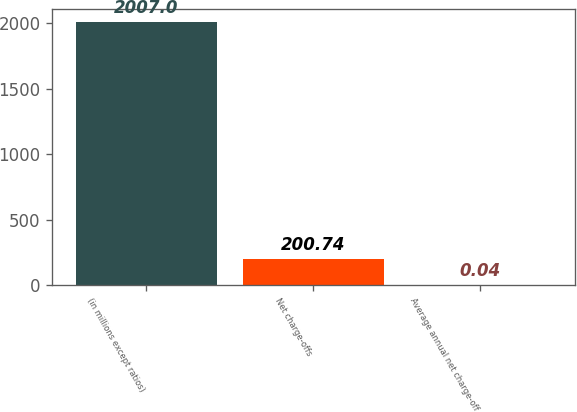<chart> <loc_0><loc_0><loc_500><loc_500><bar_chart><fcel>(in millions except ratios)<fcel>Net charge-offs<fcel>Average annual net charge-off<nl><fcel>2007<fcel>200.74<fcel>0.04<nl></chart> 